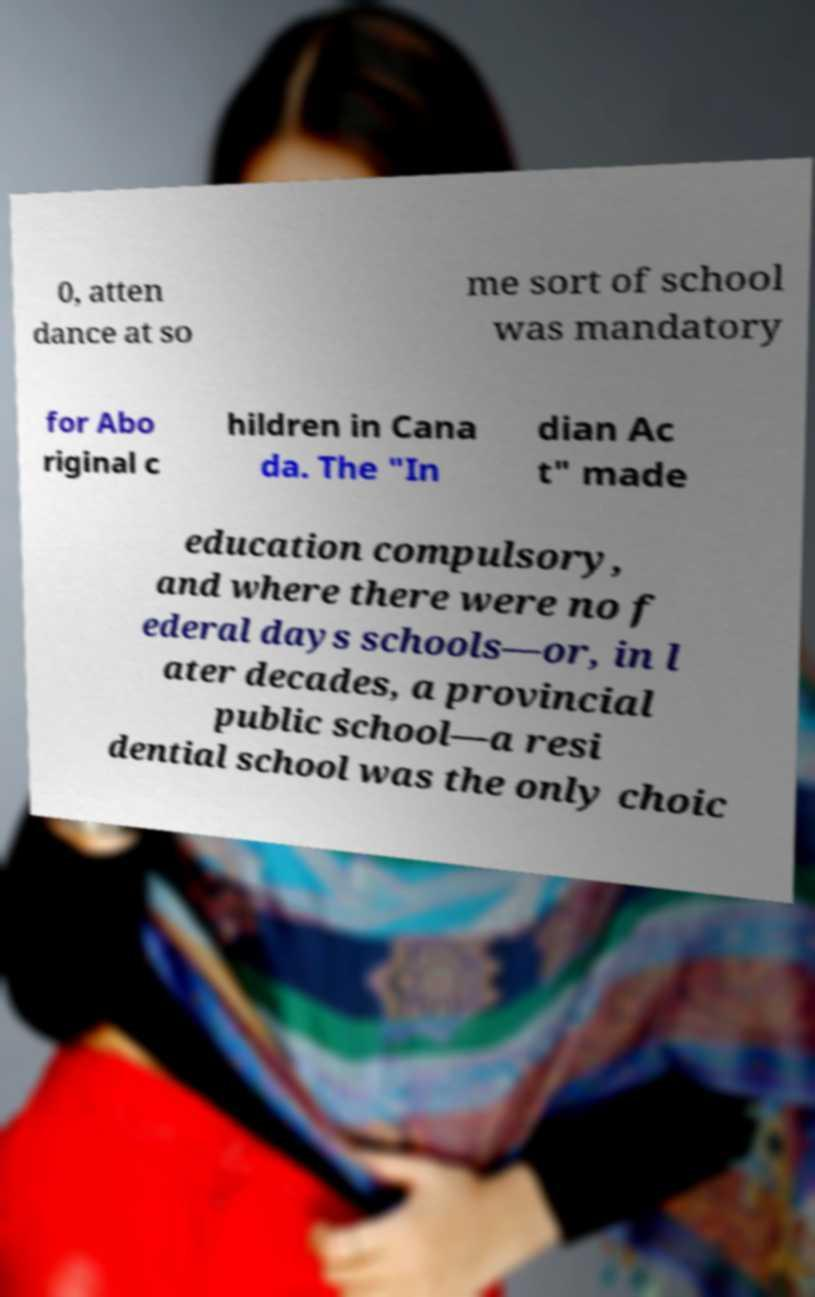What messages or text are displayed in this image? I need them in a readable, typed format. 0, atten dance at so me sort of school was mandatory for Abo riginal c hildren in Cana da. The "In dian Ac t" made education compulsory, and where there were no f ederal days schools—or, in l ater decades, a provincial public school—a resi dential school was the only choic 